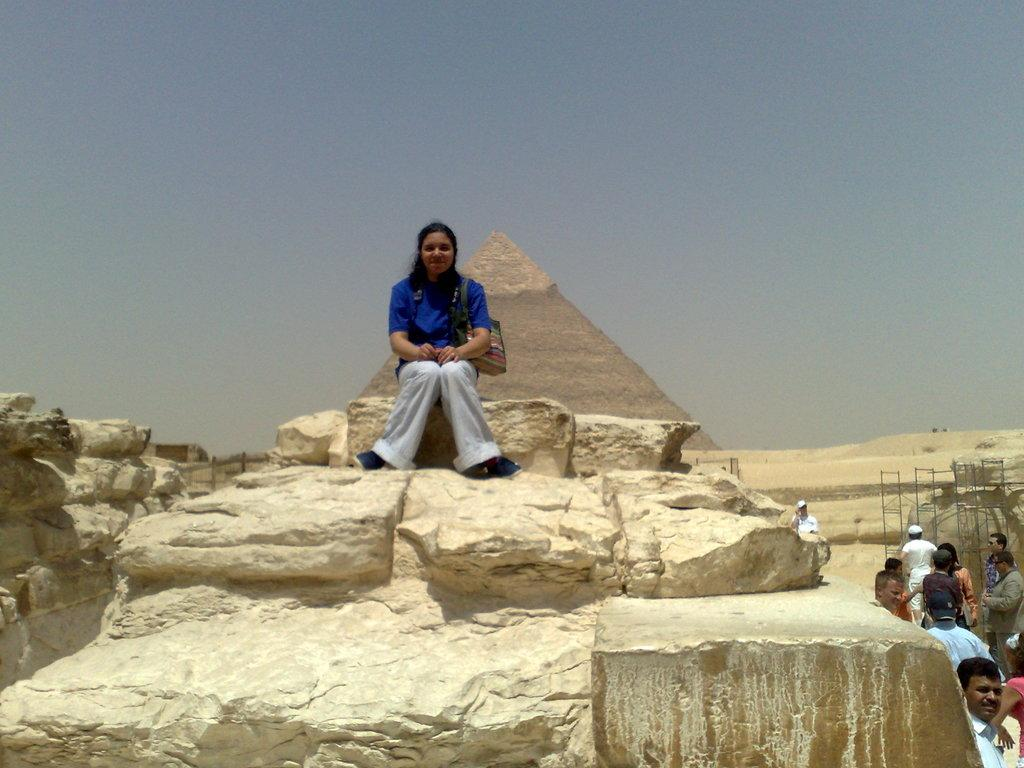What is the woman in the image doing? The woman is sitting on a stone and smiling. Where are the other people in the image located? There is a group of people on the right side of the image. What objects can be seen in the image besides the people? There are rods visible in the image. What can be seen in the background of the image? There is a pyramid and a clear sky in the background of the image. What is the name of the monkey sitting next to the woman in the image? There is no monkey present in the image; it only features a woman sitting on a stone and a group of people on the right side. 